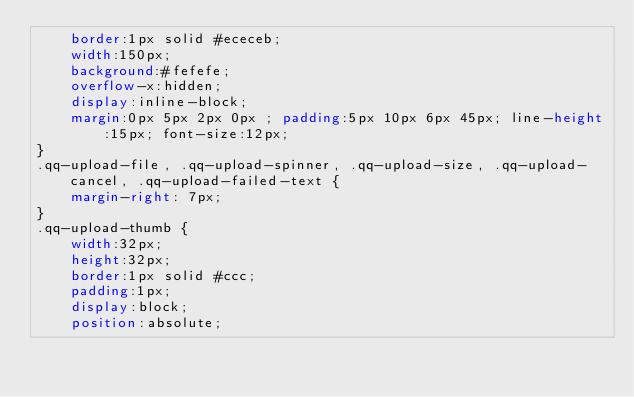<code> <loc_0><loc_0><loc_500><loc_500><_CSS_>	border:1px solid #ececeb;
	width:150px;
	background:#fefefe;
	overflow-x:hidden;
	display:inline-block;
	margin:0px 5px 2px 0px ; padding:5px 10px 6px 45px; line-height:15px; font-size:12px;
}
.qq-upload-file, .qq-upload-spinner, .qq-upload-size, .qq-upload-cancel, .qq-upload-failed-text {
    margin-right: 7px;
}
.qq-upload-thumb {
	width:32px;
	height:32px;
	border:1px solid #ccc;
	padding:1px;
	display:block;
	position:absolute;</code> 